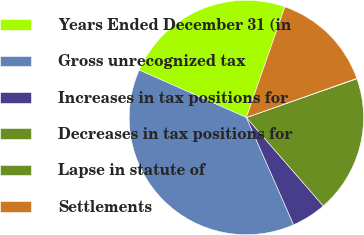<chart> <loc_0><loc_0><loc_500><loc_500><pie_chart><fcel>Years Ended December 31 (in<fcel>Gross unrecognized tax<fcel>Increases in tax positions for<fcel>Decreases in tax positions for<fcel>Lapse in statute of<fcel>Settlements<nl><fcel>23.7%<fcel>38.24%<fcel>4.79%<fcel>18.97%<fcel>0.06%<fcel>14.24%<nl></chart> 